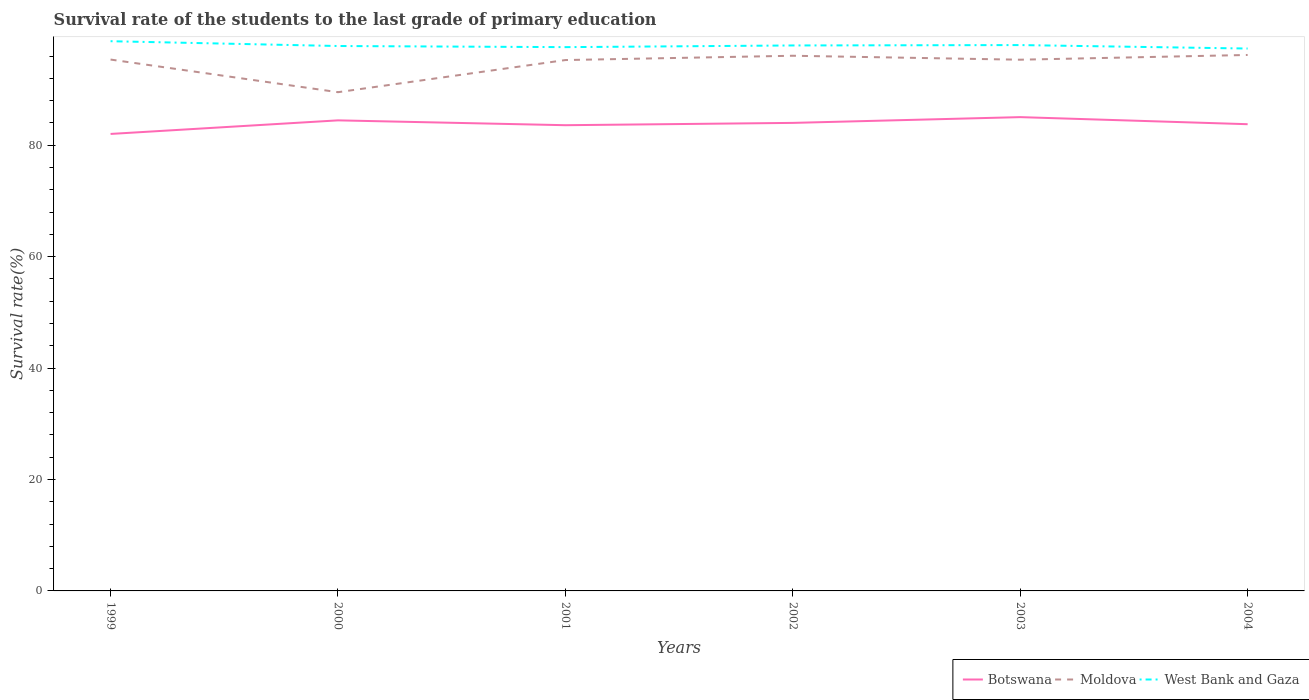Does the line corresponding to Moldova intersect with the line corresponding to Botswana?
Make the answer very short. No. Across all years, what is the maximum survival rate of the students in Moldova?
Provide a succinct answer. 89.53. In which year was the survival rate of the students in West Bank and Gaza maximum?
Offer a very short reply. 2004. What is the total survival rate of the students in Botswana in the graph?
Provide a short and direct response. -1.57. What is the difference between the highest and the second highest survival rate of the students in Moldova?
Offer a terse response. 6.68. What is the difference between the highest and the lowest survival rate of the students in Botswana?
Your answer should be compact. 3. Are the values on the major ticks of Y-axis written in scientific E-notation?
Ensure brevity in your answer.  No. Does the graph contain any zero values?
Keep it short and to the point. No. Does the graph contain grids?
Provide a succinct answer. No. How are the legend labels stacked?
Your answer should be compact. Horizontal. What is the title of the graph?
Make the answer very short. Survival rate of the students to the last grade of primary education. Does "Cyprus" appear as one of the legend labels in the graph?
Provide a succinct answer. No. What is the label or title of the X-axis?
Your answer should be very brief. Years. What is the label or title of the Y-axis?
Offer a very short reply. Survival rate(%). What is the Survival rate(%) in Botswana in 1999?
Offer a terse response. 82.03. What is the Survival rate(%) in Moldova in 1999?
Offer a terse response. 95.38. What is the Survival rate(%) in West Bank and Gaza in 1999?
Ensure brevity in your answer.  98.68. What is the Survival rate(%) in Botswana in 2000?
Offer a very short reply. 84.47. What is the Survival rate(%) in Moldova in 2000?
Provide a succinct answer. 89.53. What is the Survival rate(%) in West Bank and Gaza in 2000?
Provide a succinct answer. 97.82. What is the Survival rate(%) of Botswana in 2001?
Your answer should be compact. 83.6. What is the Survival rate(%) in Moldova in 2001?
Your response must be concise. 95.3. What is the Survival rate(%) of West Bank and Gaza in 2001?
Give a very brief answer. 97.61. What is the Survival rate(%) in Botswana in 2002?
Keep it short and to the point. 84.02. What is the Survival rate(%) of Moldova in 2002?
Provide a short and direct response. 96.07. What is the Survival rate(%) of West Bank and Gaza in 2002?
Make the answer very short. 97.92. What is the Survival rate(%) of Botswana in 2003?
Make the answer very short. 85.05. What is the Survival rate(%) of Moldova in 2003?
Offer a very short reply. 95.36. What is the Survival rate(%) of West Bank and Gaza in 2003?
Provide a short and direct response. 97.98. What is the Survival rate(%) of Botswana in 2004?
Your answer should be compact. 83.78. What is the Survival rate(%) in Moldova in 2004?
Offer a very short reply. 96.21. What is the Survival rate(%) in West Bank and Gaza in 2004?
Your answer should be very brief. 97.36. Across all years, what is the maximum Survival rate(%) in Botswana?
Your answer should be compact. 85.05. Across all years, what is the maximum Survival rate(%) in Moldova?
Offer a terse response. 96.21. Across all years, what is the maximum Survival rate(%) of West Bank and Gaza?
Make the answer very short. 98.68. Across all years, what is the minimum Survival rate(%) of Botswana?
Offer a very short reply. 82.03. Across all years, what is the minimum Survival rate(%) of Moldova?
Your response must be concise. 89.53. Across all years, what is the minimum Survival rate(%) in West Bank and Gaza?
Ensure brevity in your answer.  97.36. What is the total Survival rate(%) of Botswana in the graph?
Provide a succinct answer. 502.95. What is the total Survival rate(%) in Moldova in the graph?
Provide a succinct answer. 567.84. What is the total Survival rate(%) in West Bank and Gaza in the graph?
Your answer should be very brief. 587.37. What is the difference between the Survival rate(%) in Botswana in 1999 and that in 2000?
Provide a succinct answer. -2.44. What is the difference between the Survival rate(%) in Moldova in 1999 and that in 2000?
Provide a succinct answer. 5.86. What is the difference between the Survival rate(%) of West Bank and Gaza in 1999 and that in 2000?
Offer a terse response. 0.86. What is the difference between the Survival rate(%) of Botswana in 1999 and that in 2001?
Ensure brevity in your answer.  -1.57. What is the difference between the Survival rate(%) in Moldova in 1999 and that in 2001?
Your answer should be compact. 0.09. What is the difference between the Survival rate(%) of West Bank and Gaza in 1999 and that in 2001?
Offer a terse response. 1.06. What is the difference between the Survival rate(%) in Botswana in 1999 and that in 2002?
Provide a short and direct response. -1.98. What is the difference between the Survival rate(%) of Moldova in 1999 and that in 2002?
Provide a short and direct response. -0.68. What is the difference between the Survival rate(%) of West Bank and Gaza in 1999 and that in 2002?
Ensure brevity in your answer.  0.76. What is the difference between the Survival rate(%) of Botswana in 1999 and that in 2003?
Give a very brief answer. -3.02. What is the difference between the Survival rate(%) of Moldova in 1999 and that in 2003?
Keep it short and to the point. 0.03. What is the difference between the Survival rate(%) in West Bank and Gaza in 1999 and that in 2003?
Keep it short and to the point. 0.69. What is the difference between the Survival rate(%) in Botswana in 1999 and that in 2004?
Offer a very short reply. -1.75. What is the difference between the Survival rate(%) of Moldova in 1999 and that in 2004?
Provide a short and direct response. -0.82. What is the difference between the Survival rate(%) of West Bank and Gaza in 1999 and that in 2004?
Make the answer very short. 1.31. What is the difference between the Survival rate(%) of Botswana in 2000 and that in 2001?
Your response must be concise. 0.87. What is the difference between the Survival rate(%) of Moldova in 2000 and that in 2001?
Your answer should be very brief. -5.77. What is the difference between the Survival rate(%) of West Bank and Gaza in 2000 and that in 2001?
Your answer should be compact. 0.2. What is the difference between the Survival rate(%) in Botswana in 2000 and that in 2002?
Your answer should be compact. 0.45. What is the difference between the Survival rate(%) of Moldova in 2000 and that in 2002?
Make the answer very short. -6.54. What is the difference between the Survival rate(%) of West Bank and Gaza in 2000 and that in 2002?
Provide a succinct answer. -0.1. What is the difference between the Survival rate(%) of Botswana in 2000 and that in 2003?
Provide a succinct answer. -0.58. What is the difference between the Survival rate(%) in Moldova in 2000 and that in 2003?
Ensure brevity in your answer.  -5.83. What is the difference between the Survival rate(%) in West Bank and Gaza in 2000 and that in 2003?
Offer a very short reply. -0.17. What is the difference between the Survival rate(%) in Botswana in 2000 and that in 2004?
Provide a short and direct response. 0.69. What is the difference between the Survival rate(%) of Moldova in 2000 and that in 2004?
Give a very brief answer. -6.68. What is the difference between the Survival rate(%) in West Bank and Gaza in 2000 and that in 2004?
Provide a succinct answer. 0.45. What is the difference between the Survival rate(%) of Botswana in 2001 and that in 2002?
Provide a succinct answer. -0.42. What is the difference between the Survival rate(%) in Moldova in 2001 and that in 2002?
Your answer should be very brief. -0.77. What is the difference between the Survival rate(%) in West Bank and Gaza in 2001 and that in 2002?
Keep it short and to the point. -0.3. What is the difference between the Survival rate(%) in Botswana in 2001 and that in 2003?
Give a very brief answer. -1.45. What is the difference between the Survival rate(%) in Moldova in 2001 and that in 2003?
Your answer should be compact. -0.06. What is the difference between the Survival rate(%) in West Bank and Gaza in 2001 and that in 2003?
Offer a very short reply. -0.37. What is the difference between the Survival rate(%) in Botswana in 2001 and that in 2004?
Keep it short and to the point. -0.18. What is the difference between the Survival rate(%) in Moldova in 2001 and that in 2004?
Give a very brief answer. -0.91. What is the difference between the Survival rate(%) of West Bank and Gaza in 2001 and that in 2004?
Ensure brevity in your answer.  0.25. What is the difference between the Survival rate(%) of Botswana in 2002 and that in 2003?
Your response must be concise. -1.03. What is the difference between the Survival rate(%) in Moldova in 2002 and that in 2003?
Offer a terse response. 0.71. What is the difference between the Survival rate(%) in West Bank and Gaza in 2002 and that in 2003?
Make the answer very short. -0.07. What is the difference between the Survival rate(%) in Botswana in 2002 and that in 2004?
Give a very brief answer. 0.24. What is the difference between the Survival rate(%) of Moldova in 2002 and that in 2004?
Offer a terse response. -0.14. What is the difference between the Survival rate(%) in West Bank and Gaza in 2002 and that in 2004?
Make the answer very short. 0.55. What is the difference between the Survival rate(%) of Botswana in 2003 and that in 2004?
Ensure brevity in your answer.  1.27. What is the difference between the Survival rate(%) of Moldova in 2003 and that in 2004?
Your answer should be compact. -0.85. What is the difference between the Survival rate(%) in West Bank and Gaza in 2003 and that in 2004?
Offer a very short reply. 0.62. What is the difference between the Survival rate(%) of Botswana in 1999 and the Survival rate(%) of Moldova in 2000?
Offer a terse response. -7.49. What is the difference between the Survival rate(%) of Botswana in 1999 and the Survival rate(%) of West Bank and Gaza in 2000?
Provide a succinct answer. -15.78. What is the difference between the Survival rate(%) in Moldova in 1999 and the Survival rate(%) in West Bank and Gaza in 2000?
Provide a short and direct response. -2.43. What is the difference between the Survival rate(%) in Botswana in 1999 and the Survival rate(%) in Moldova in 2001?
Give a very brief answer. -13.26. What is the difference between the Survival rate(%) of Botswana in 1999 and the Survival rate(%) of West Bank and Gaza in 2001?
Your answer should be very brief. -15.58. What is the difference between the Survival rate(%) of Moldova in 1999 and the Survival rate(%) of West Bank and Gaza in 2001?
Offer a terse response. -2.23. What is the difference between the Survival rate(%) in Botswana in 1999 and the Survival rate(%) in Moldova in 2002?
Your answer should be very brief. -14.04. What is the difference between the Survival rate(%) of Botswana in 1999 and the Survival rate(%) of West Bank and Gaza in 2002?
Keep it short and to the point. -15.88. What is the difference between the Survival rate(%) of Moldova in 1999 and the Survival rate(%) of West Bank and Gaza in 2002?
Ensure brevity in your answer.  -2.53. What is the difference between the Survival rate(%) in Botswana in 1999 and the Survival rate(%) in Moldova in 2003?
Provide a short and direct response. -13.32. What is the difference between the Survival rate(%) of Botswana in 1999 and the Survival rate(%) of West Bank and Gaza in 2003?
Keep it short and to the point. -15.95. What is the difference between the Survival rate(%) in Moldova in 1999 and the Survival rate(%) in West Bank and Gaza in 2003?
Give a very brief answer. -2.6. What is the difference between the Survival rate(%) in Botswana in 1999 and the Survival rate(%) in Moldova in 2004?
Keep it short and to the point. -14.18. What is the difference between the Survival rate(%) in Botswana in 1999 and the Survival rate(%) in West Bank and Gaza in 2004?
Provide a short and direct response. -15.33. What is the difference between the Survival rate(%) in Moldova in 1999 and the Survival rate(%) in West Bank and Gaza in 2004?
Offer a very short reply. -1.98. What is the difference between the Survival rate(%) of Botswana in 2000 and the Survival rate(%) of Moldova in 2001?
Give a very brief answer. -10.82. What is the difference between the Survival rate(%) of Botswana in 2000 and the Survival rate(%) of West Bank and Gaza in 2001?
Your answer should be compact. -13.14. What is the difference between the Survival rate(%) of Moldova in 2000 and the Survival rate(%) of West Bank and Gaza in 2001?
Your response must be concise. -8.09. What is the difference between the Survival rate(%) of Botswana in 2000 and the Survival rate(%) of Moldova in 2002?
Your response must be concise. -11.6. What is the difference between the Survival rate(%) in Botswana in 2000 and the Survival rate(%) in West Bank and Gaza in 2002?
Provide a succinct answer. -13.44. What is the difference between the Survival rate(%) of Moldova in 2000 and the Survival rate(%) of West Bank and Gaza in 2002?
Ensure brevity in your answer.  -8.39. What is the difference between the Survival rate(%) in Botswana in 2000 and the Survival rate(%) in Moldova in 2003?
Offer a very short reply. -10.89. What is the difference between the Survival rate(%) of Botswana in 2000 and the Survival rate(%) of West Bank and Gaza in 2003?
Offer a very short reply. -13.51. What is the difference between the Survival rate(%) in Moldova in 2000 and the Survival rate(%) in West Bank and Gaza in 2003?
Ensure brevity in your answer.  -8.46. What is the difference between the Survival rate(%) of Botswana in 2000 and the Survival rate(%) of Moldova in 2004?
Your response must be concise. -11.74. What is the difference between the Survival rate(%) of Botswana in 2000 and the Survival rate(%) of West Bank and Gaza in 2004?
Provide a short and direct response. -12.89. What is the difference between the Survival rate(%) of Moldova in 2000 and the Survival rate(%) of West Bank and Gaza in 2004?
Provide a succinct answer. -7.84. What is the difference between the Survival rate(%) in Botswana in 2001 and the Survival rate(%) in Moldova in 2002?
Offer a terse response. -12.47. What is the difference between the Survival rate(%) in Botswana in 2001 and the Survival rate(%) in West Bank and Gaza in 2002?
Give a very brief answer. -14.31. What is the difference between the Survival rate(%) of Moldova in 2001 and the Survival rate(%) of West Bank and Gaza in 2002?
Your answer should be very brief. -2.62. What is the difference between the Survival rate(%) in Botswana in 2001 and the Survival rate(%) in Moldova in 2003?
Provide a short and direct response. -11.76. What is the difference between the Survival rate(%) in Botswana in 2001 and the Survival rate(%) in West Bank and Gaza in 2003?
Give a very brief answer. -14.38. What is the difference between the Survival rate(%) of Moldova in 2001 and the Survival rate(%) of West Bank and Gaza in 2003?
Offer a very short reply. -2.69. What is the difference between the Survival rate(%) in Botswana in 2001 and the Survival rate(%) in Moldova in 2004?
Provide a short and direct response. -12.61. What is the difference between the Survival rate(%) in Botswana in 2001 and the Survival rate(%) in West Bank and Gaza in 2004?
Provide a succinct answer. -13.76. What is the difference between the Survival rate(%) of Moldova in 2001 and the Survival rate(%) of West Bank and Gaza in 2004?
Your response must be concise. -2.07. What is the difference between the Survival rate(%) in Botswana in 2002 and the Survival rate(%) in Moldova in 2003?
Your answer should be compact. -11.34. What is the difference between the Survival rate(%) of Botswana in 2002 and the Survival rate(%) of West Bank and Gaza in 2003?
Provide a succinct answer. -13.97. What is the difference between the Survival rate(%) in Moldova in 2002 and the Survival rate(%) in West Bank and Gaza in 2003?
Keep it short and to the point. -1.92. What is the difference between the Survival rate(%) in Botswana in 2002 and the Survival rate(%) in Moldova in 2004?
Provide a short and direct response. -12.19. What is the difference between the Survival rate(%) of Botswana in 2002 and the Survival rate(%) of West Bank and Gaza in 2004?
Your answer should be compact. -13.35. What is the difference between the Survival rate(%) in Moldova in 2002 and the Survival rate(%) in West Bank and Gaza in 2004?
Offer a very short reply. -1.29. What is the difference between the Survival rate(%) in Botswana in 2003 and the Survival rate(%) in Moldova in 2004?
Ensure brevity in your answer.  -11.16. What is the difference between the Survival rate(%) in Botswana in 2003 and the Survival rate(%) in West Bank and Gaza in 2004?
Keep it short and to the point. -12.31. What is the difference between the Survival rate(%) of Moldova in 2003 and the Survival rate(%) of West Bank and Gaza in 2004?
Keep it short and to the point. -2.01. What is the average Survival rate(%) in Botswana per year?
Your answer should be very brief. 83.83. What is the average Survival rate(%) in Moldova per year?
Your answer should be very brief. 94.64. What is the average Survival rate(%) in West Bank and Gaza per year?
Keep it short and to the point. 97.9. In the year 1999, what is the difference between the Survival rate(%) in Botswana and Survival rate(%) in Moldova?
Give a very brief answer. -13.35. In the year 1999, what is the difference between the Survival rate(%) of Botswana and Survival rate(%) of West Bank and Gaza?
Your answer should be compact. -16.64. In the year 1999, what is the difference between the Survival rate(%) of Moldova and Survival rate(%) of West Bank and Gaza?
Provide a short and direct response. -3.29. In the year 2000, what is the difference between the Survival rate(%) in Botswana and Survival rate(%) in Moldova?
Your answer should be compact. -5.05. In the year 2000, what is the difference between the Survival rate(%) in Botswana and Survival rate(%) in West Bank and Gaza?
Make the answer very short. -13.35. In the year 2000, what is the difference between the Survival rate(%) in Moldova and Survival rate(%) in West Bank and Gaza?
Offer a terse response. -8.29. In the year 2001, what is the difference between the Survival rate(%) in Botswana and Survival rate(%) in Moldova?
Give a very brief answer. -11.69. In the year 2001, what is the difference between the Survival rate(%) in Botswana and Survival rate(%) in West Bank and Gaza?
Your answer should be very brief. -14.01. In the year 2001, what is the difference between the Survival rate(%) in Moldova and Survival rate(%) in West Bank and Gaza?
Your response must be concise. -2.32. In the year 2002, what is the difference between the Survival rate(%) in Botswana and Survival rate(%) in Moldova?
Keep it short and to the point. -12.05. In the year 2002, what is the difference between the Survival rate(%) in Botswana and Survival rate(%) in West Bank and Gaza?
Keep it short and to the point. -13.9. In the year 2002, what is the difference between the Survival rate(%) in Moldova and Survival rate(%) in West Bank and Gaza?
Ensure brevity in your answer.  -1.85. In the year 2003, what is the difference between the Survival rate(%) in Botswana and Survival rate(%) in Moldova?
Your response must be concise. -10.31. In the year 2003, what is the difference between the Survival rate(%) of Botswana and Survival rate(%) of West Bank and Gaza?
Offer a very short reply. -12.93. In the year 2003, what is the difference between the Survival rate(%) of Moldova and Survival rate(%) of West Bank and Gaza?
Ensure brevity in your answer.  -2.63. In the year 2004, what is the difference between the Survival rate(%) in Botswana and Survival rate(%) in Moldova?
Make the answer very short. -12.43. In the year 2004, what is the difference between the Survival rate(%) of Botswana and Survival rate(%) of West Bank and Gaza?
Provide a short and direct response. -13.58. In the year 2004, what is the difference between the Survival rate(%) of Moldova and Survival rate(%) of West Bank and Gaza?
Provide a succinct answer. -1.15. What is the ratio of the Survival rate(%) of Botswana in 1999 to that in 2000?
Provide a succinct answer. 0.97. What is the ratio of the Survival rate(%) of Moldova in 1999 to that in 2000?
Offer a terse response. 1.07. What is the ratio of the Survival rate(%) of West Bank and Gaza in 1999 to that in 2000?
Your answer should be very brief. 1.01. What is the ratio of the Survival rate(%) in Botswana in 1999 to that in 2001?
Give a very brief answer. 0.98. What is the ratio of the Survival rate(%) in West Bank and Gaza in 1999 to that in 2001?
Your answer should be compact. 1.01. What is the ratio of the Survival rate(%) in Botswana in 1999 to that in 2002?
Offer a very short reply. 0.98. What is the ratio of the Survival rate(%) in West Bank and Gaza in 1999 to that in 2002?
Give a very brief answer. 1.01. What is the ratio of the Survival rate(%) of Botswana in 1999 to that in 2003?
Make the answer very short. 0.96. What is the ratio of the Survival rate(%) in West Bank and Gaza in 1999 to that in 2003?
Your answer should be compact. 1.01. What is the ratio of the Survival rate(%) of Botswana in 1999 to that in 2004?
Offer a very short reply. 0.98. What is the ratio of the Survival rate(%) in Moldova in 1999 to that in 2004?
Give a very brief answer. 0.99. What is the ratio of the Survival rate(%) in West Bank and Gaza in 1999 to that in 2004?
Give a very brief answer. 1.01. What is the ratio of the Survival rate(%) in Botswana in 2000 to that in 2001?
Offer a very short reply. 1.01. What is the ratio of the Survival rate(%) of Moldova in 2000 to that in 2001?
Make the answer very short. 0.94. What is the ratio of the Survival rate(%) in West Bank and Gaza in 2000 to that in 2001?
Offer a terse response. 1. What is the ratio of the Survival rate(%) of Botswana in 2000 to that in 2002?
Offer a terse response. 1.01. What is the ratio of the Survival rate(%) of Moldova in 2000 to that in 2002?
Your answer should be compact. 0.93. What is the ratio of the Survival rate(%) in West Bank and Gaza in 2000 to that in 2002?
Ensure brevity in your answer.  1. What is the ratio of the Survival rate(%) in Moldova in 2000 to that in 2003?
Your answer should be compact. 0.94. What is the ratio of the Survival rate(%) of Botswana in 2000 to that in 2004?
Your response must be concise. 1.01. What is the ratio of the Survival rate(%) in Moldova in 2000 to that in 2004?
Offer a terse response. 0.93. What is the ratio of the Survival rate(%) in West Bank and Gaza in 2000 to that in 2004?
Your answer should be very brief. 1. What is the ratio of the Survival rate(%) of Moldova in 2001 to that in 2002?
Your answer should be very brief. 0.99. What is the ratio of the Survival rate(%) in Moldova in 2001 to that in 2003?
Your answer should be compact. 1. What is the ratio of the Survival rate(%) of West Bank and Gaza in 2001 to that in 2003?
Offer a very short reply. 1. What is the ratio of the Survival rate(%) of Botswana in 2002 to that in 2003?
Give a very brief answer. 0.99. What is the ratio of the Survival rate(%) of Moldova in 2002 to that in 2003?
Give a very brief answer. 1.01. What is the ratio of the Survival rate(%) in Botswana in 2003 to that in 2004?
Give a very brief answer. 1.02. What is the ratio of the Survival rate(%) in West Bank and Gaza in 2003 to that in 2004?
Give a very brief answer. 1.01. What is the difference between the highest and the second highest Survival rate(%) in Botswana?
Ensure brevity in your answer.  0.58. What is the difference between the highest and the second highest Survival rate(%) of Moldova?
Offer a very short reply. 0.14. What is the difference between the highest and the second highest Survival rate(%) of West Bank and Gaza?
Give a very brief answer. 0.69. What is the difference between the highest and the lowest Survival rate(%) in Botswana?
Keep it short and to the point. 3.02. What is the difference between the highest and the lowest Survival rate(%) of Moldova?
Give a very brief answer. 6.68. What is the difference between the highest and the lowest Survival rate(%) of West Bank and Gaza?
Provide a short and direct response. 1.31. 